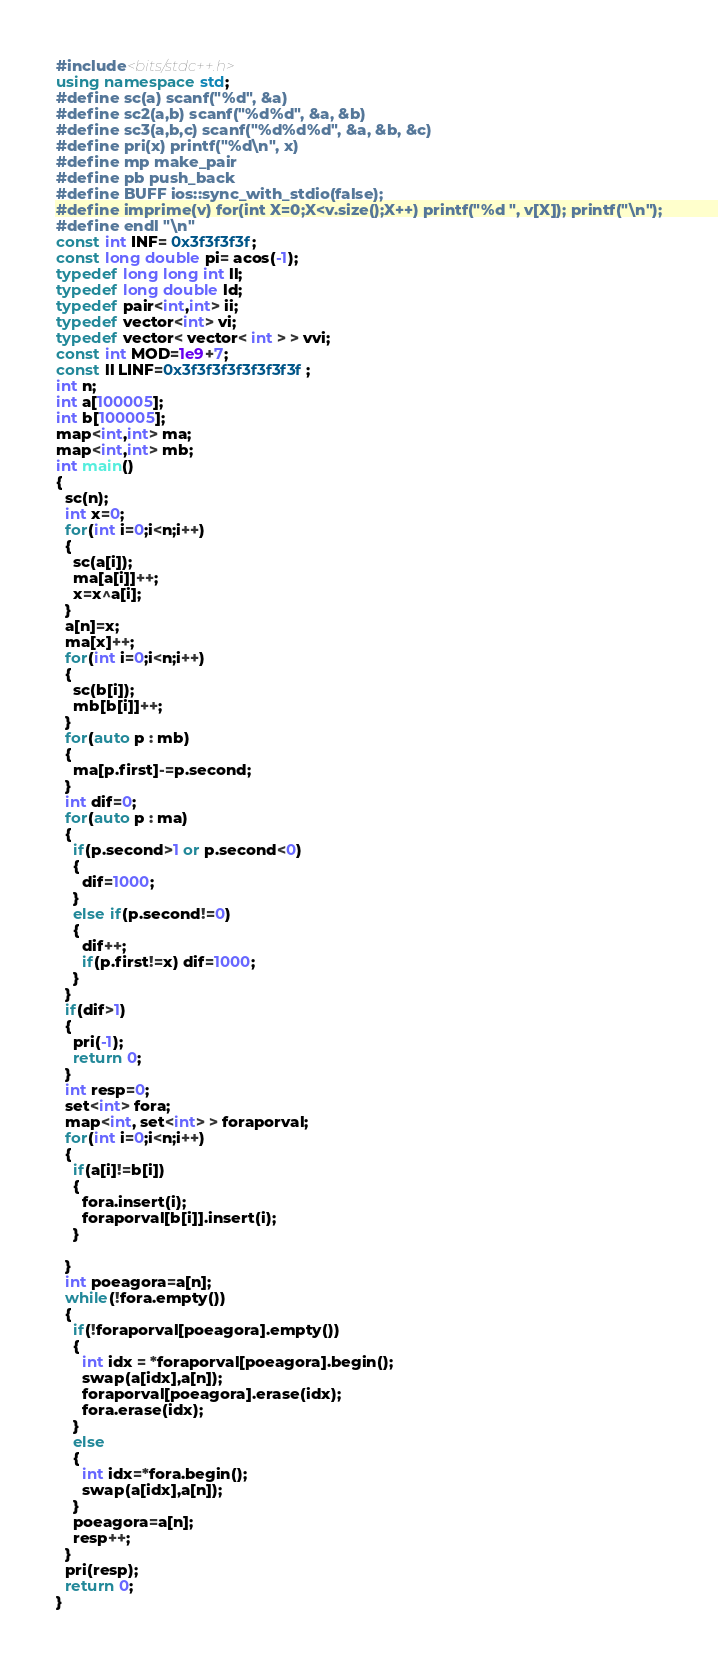<code> <loc_0><loc_0><loc_500><loc_500><_C++_>#include<bits/stdc++.h>
using namespace std;
#define sc(a) scanf("%d", &a)
#define sc2(a,b) scanf("%d%d", &a, &b)
#define sc3(a,b,c) scanf("%d%d%d", &a, &b, &c)
#define pri(x) printf("%d\n", x)
#define mp make_pair
#define pb push_back
#define BUFF ios::sync_with_stdio(false);
#define imprime(v) for(int X=0;X<v.size();X++) printf("%d ", v[X]); printf("\n");
#define endl "\n"
const int INF= 0x3f3f3f3f;
const long double pi= acos(-1);
typedef long long int ll;
typedef long double ld;
typedef pair<int,int> ii;
typedef vector<int> vi;
typedef vector< vector< int > > vvi;
const int MOD=1e9+7;
const ll LINF=0x3f3f3f3f3f3f3f3f;
int n;
int a[100005];
int b[100005];
map<int,int> ma;
map<int,int> mb;
int main()
{
  sc(n);
  int x=0;
  for(int i=0;i<n;i++)
  {
    sc(a[i]);
    ma[a[i]]++;
    x=x^a[i];
  }
  a[n]=x;
  ma[x]++;
  for(int i=0;i<n;i++)
  {
    sc(b[i]);
    mb[b[i]]++;
  }
  for(auto p : mb)
  {
    ma[p.first]-=p.second;
  }
  int dif=0;
  for(auto p : ma)
  {
    if(p.second>1 or p.second<0)
    {
      dif=1000;
    }
    else if(p.second!=0)
    {
      dif++;
      if(p.first!=x) dif=1000;
    }
  }
  if(dif>1)
  {
    pri(-1);
    return 0;
  }
  int resp=0;
  set<int> fora;
  map<int, set<int> > foraporval;
  for(int i=0;i<n;i++)
  {
    if(a[i]!=b[i])
    {
      fora.insert(i);
      foraporval[b[i]].insert(i);
    }

  }
  int poeagora=a[n];
  while(!fora.empty())
  {
    if(!foraporval[poeagora].empty())
    {
      int idx = *foraporval[poeagora].begin();
      swap(a[idx],a[n]);
      foraporval[poeagora].erase(idx);
      fora.erase(idx);
    }
    else
    {
      int idx=*fora.begin();
      swap(a[idx],a[n]);
    }
    poeagora=a[n];
    resp++;
  }
  pri(resp);
  return 0;
}


















</code> 